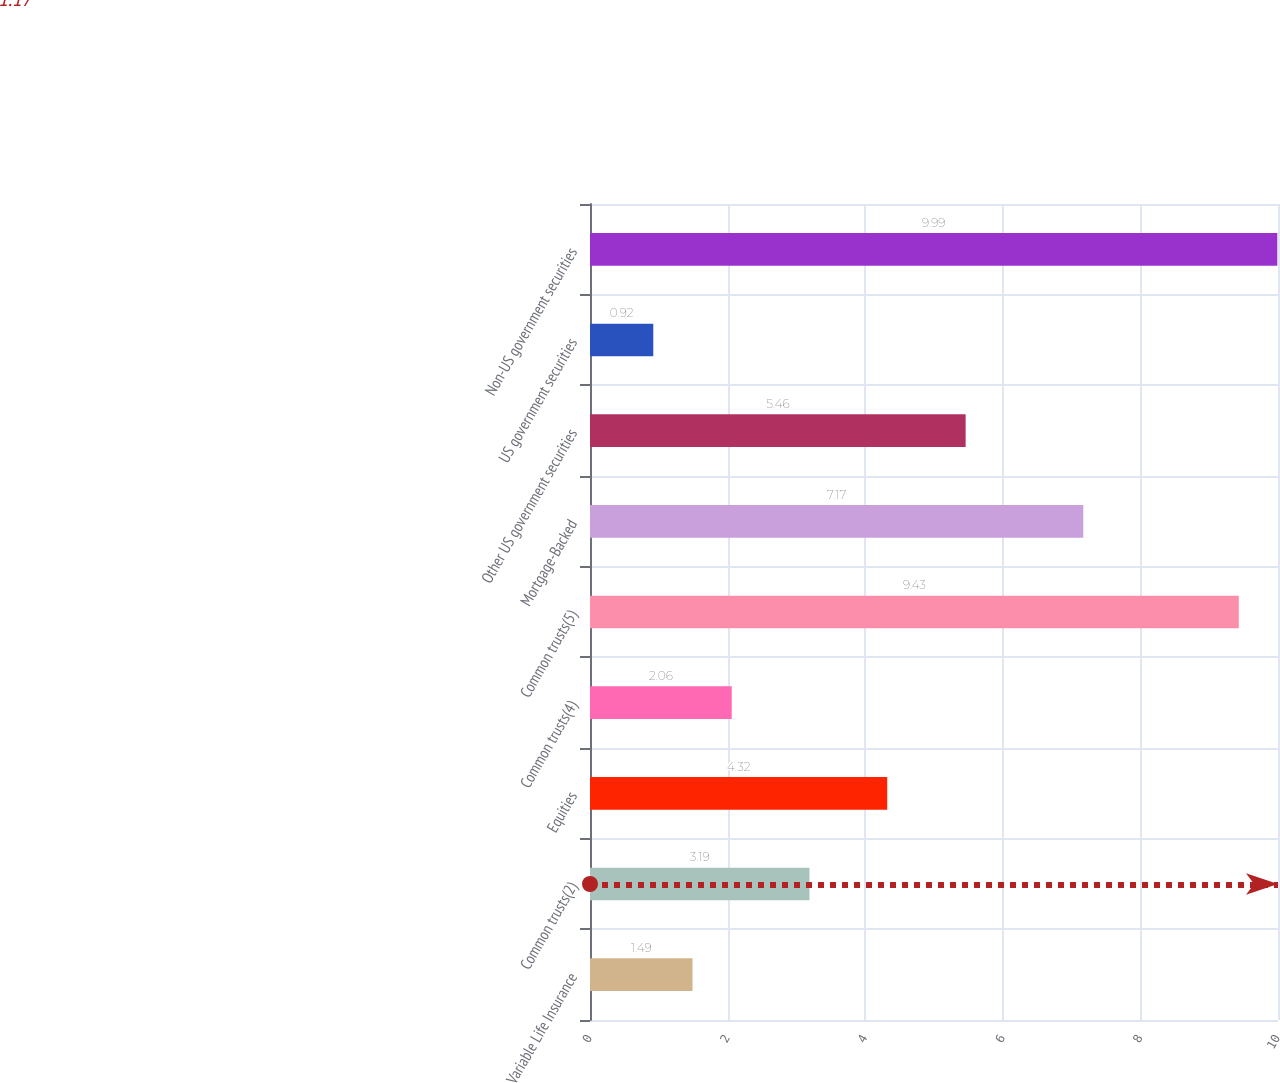<chart> <loc_0><loc_0><loc_500><loc_500><bar_chart><fcel>Variable Life Insurance<fcel>Common trusts(2)<fcel>Equities<fcel>Common trusts(4)<fcel>Common trusts(5)<fcel>Mortgage-Backed<fcel>Other US government securities<fcel>US government securities<fcel>Non-US government securities<nl><fcel>1.49<fcel>3.19<fcel>4.32<fcel>2.06<fcel>9.43<fcel>7.17<fcel>5.46<fcel>0.92<fcel>9.99<nl></chart> 